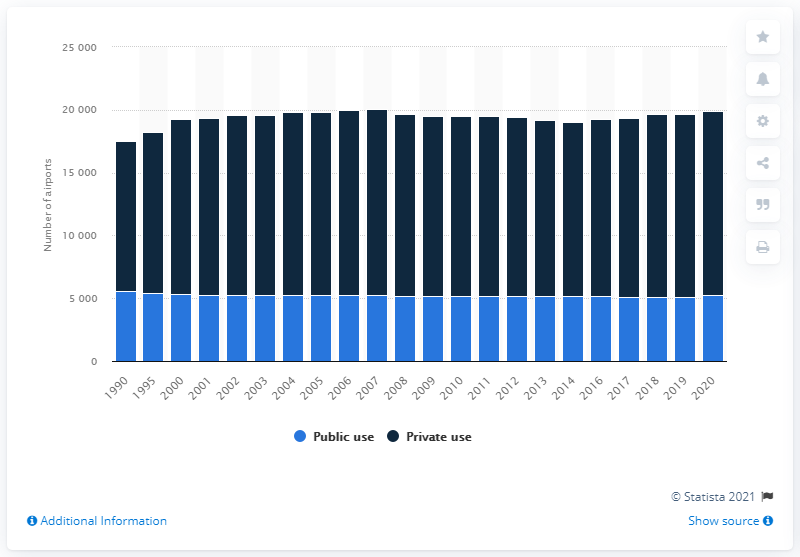Outline some significant characteristics in this image. Since 1990, the number of public use airports in the United States has decreased. 